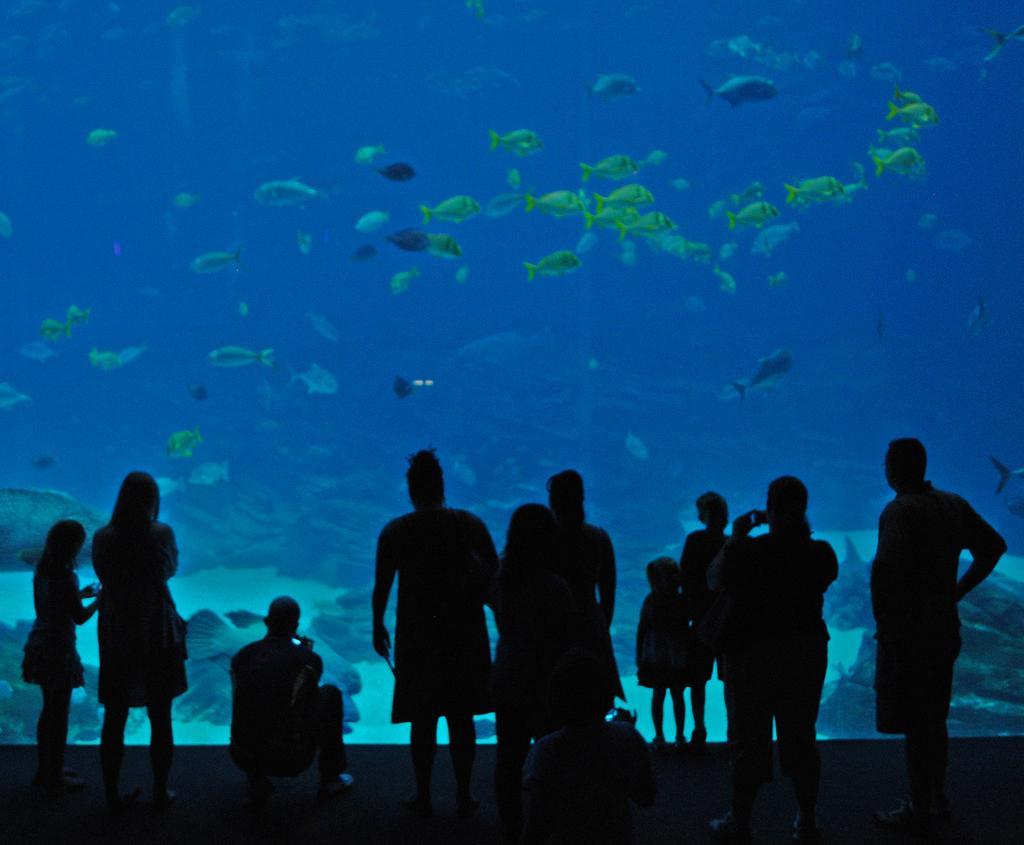How would you summarize this image in a sentence or two? In this image there are a few people standing, in front of the glass through which we can see the fishes and shells in the water. 